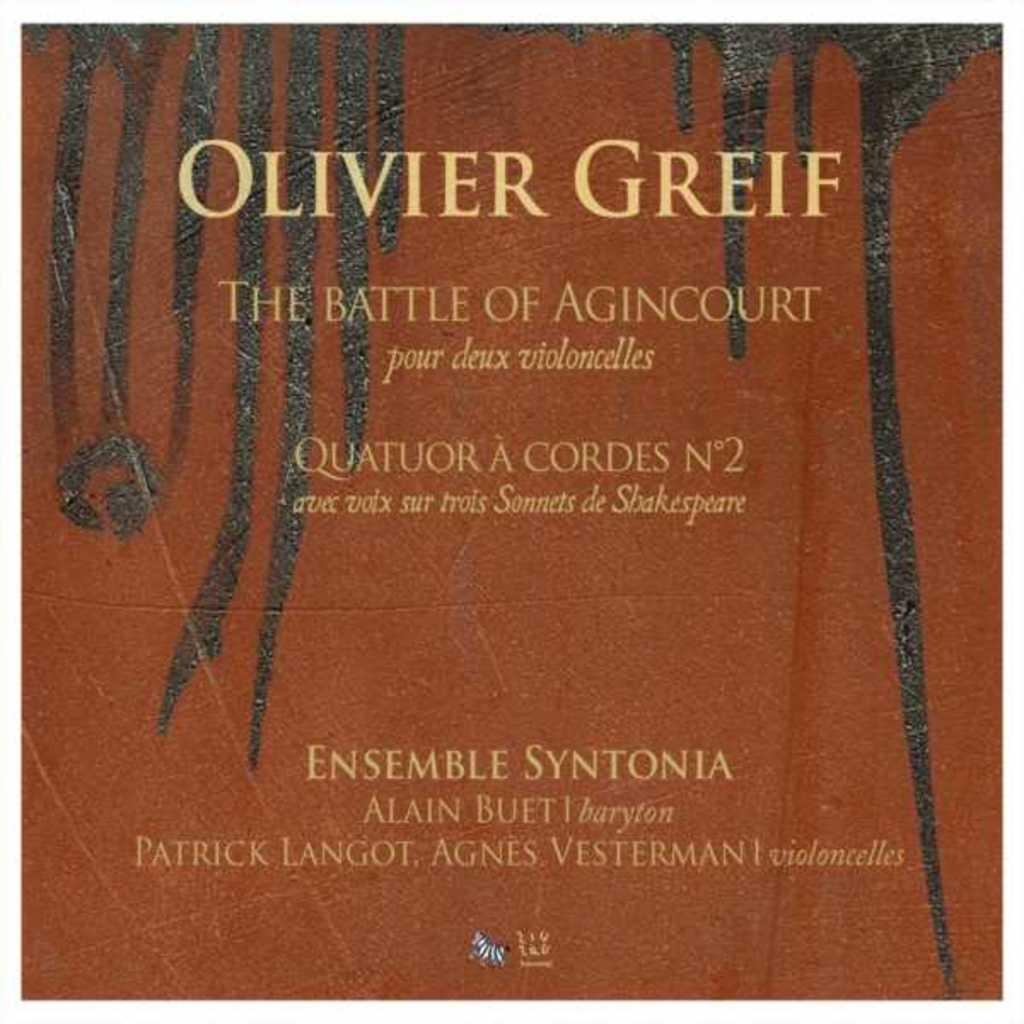<image>
Share a concise interpretation of the image provided. an album cover from Olivere Greif The battle of Agincourt 